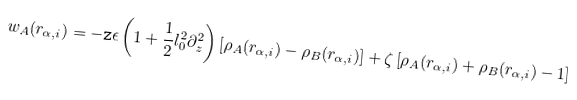Convert formula to latex. <formula><loc_0><loc_0><loc_500><loc_500>w _ { A } ( r _ { \alpha , i } ) = - { \tt z } \epsilon \left ( 1 + \frac { 1 } { 2 } l _ { 0 } ^ { 2 } \partial _ { z } ^ { 2 } \right ) \left [ \rho _ { A } ( r _ { \alpha , i } ) - \rho _ { B } ( r _ { \alpha , i } ) \right ] + \zeta \left [ \rho _ { A } ( r _ { \alpha , i } ) + \rho _ { B } ( r _ { \alpha , i } ) - 1 \right ]</formula> 